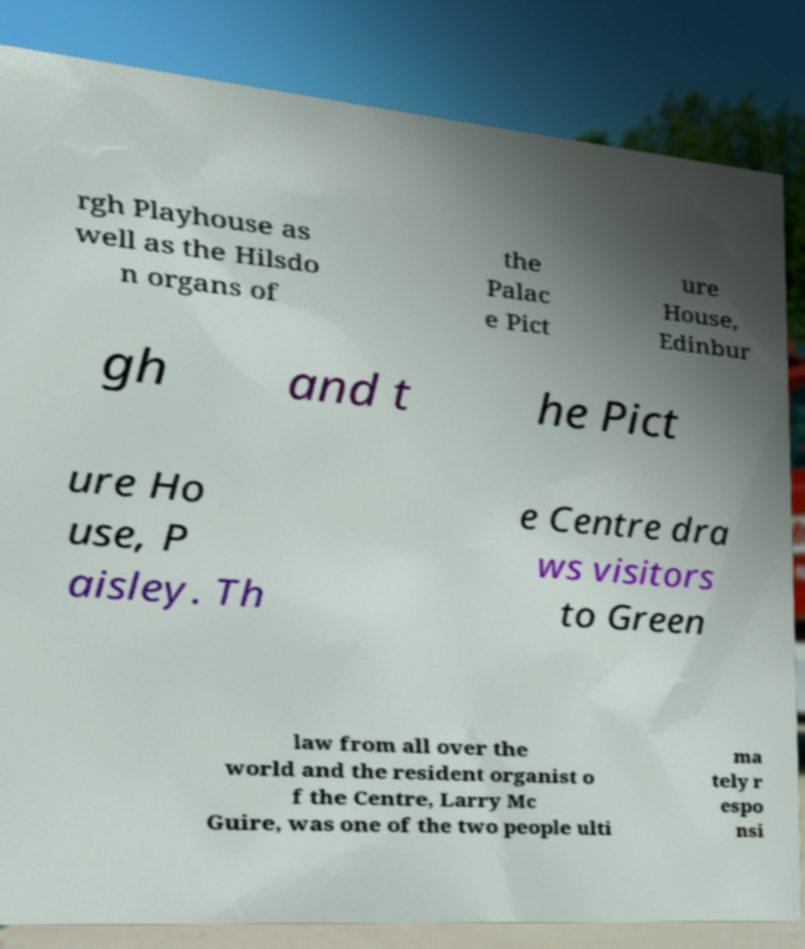There's text embedded in this image that I need extracted. Can you transcribe it verbatim? rgh Playhouse as well as the Hilsdo n organs of the Palac e Pict ure House, Edinbur gh and t he Pict ure Ho use, P aisley. Th e Centre dra ws visitors to Green law from all over the world and the resident organist o f the Centre, Larry Mc Guire, was one of the two people ulti ma tely r espo nsi 